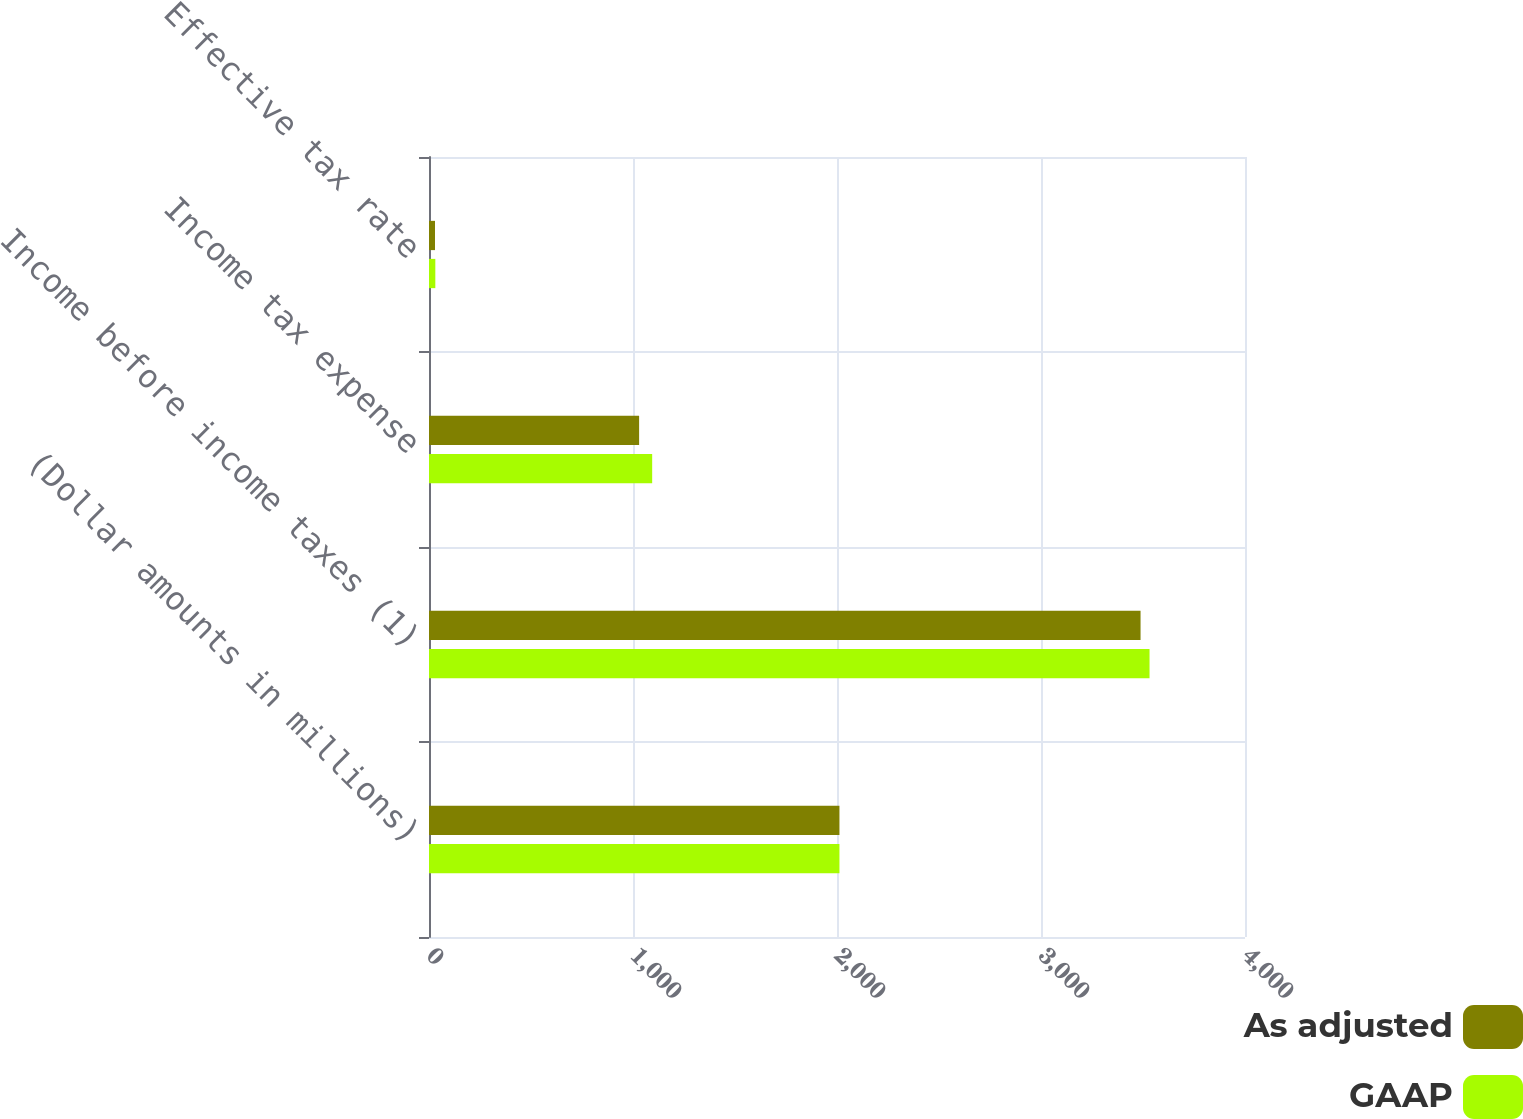Convert chart to OTSL. <chart><loc_0><loc_0><loc_500><loc_500><stacked_bar_chart><ecel><fcel>(Dollar amounts in millions)<fcel>Income before income taxes (1)<fcel>Income tax expense<fcel>Effective tax rate<nl><fcel>As adjusted<fcel>2012<fcel>3488<fcel>1030<fcel>29.5<nl><fcel>GAAP<fcel>2012<fcel>3532<fcel>1094<fcel>31<nl></chart> 